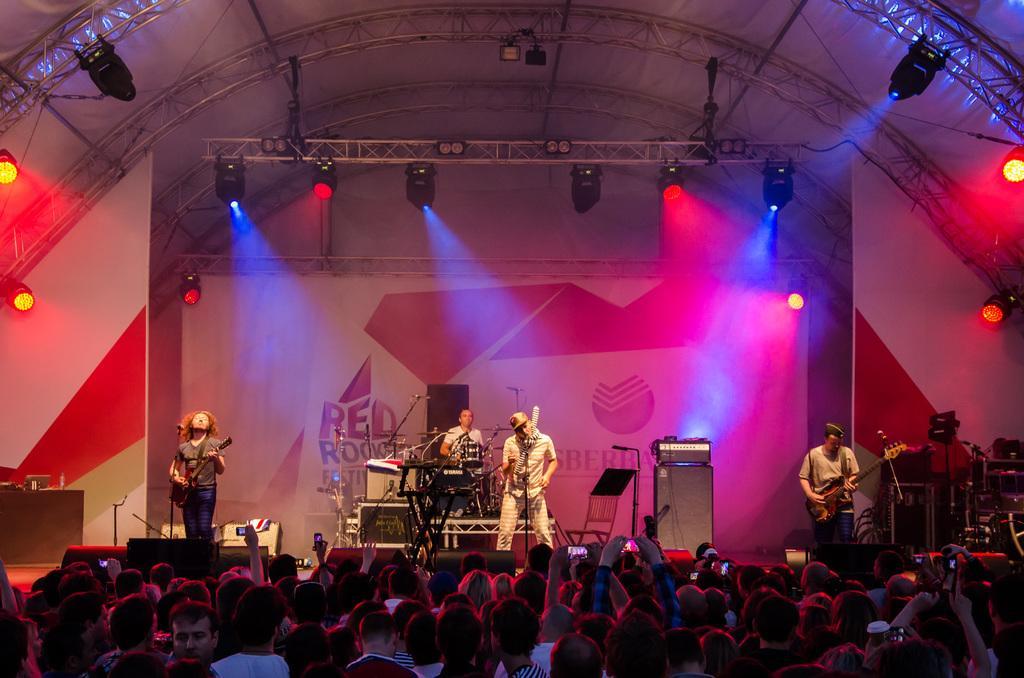In one or two sentences, can you explain what this image depicts? In this picture we can see four persons on the stage, a person on the left side is playing a guitar, a person in the back is playing drums, we can see microphones here, at the bottom there are some people, we can see lights at the top of the picture. 